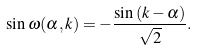Convert formula to latex. <formula><loc_0><loc_0><loc_500><loc_500>\sin \omega ( \alpha , k ) = - \frac { \sin { ( k - \alpha ) } } { \sqrt { 2 } } .</formula> 